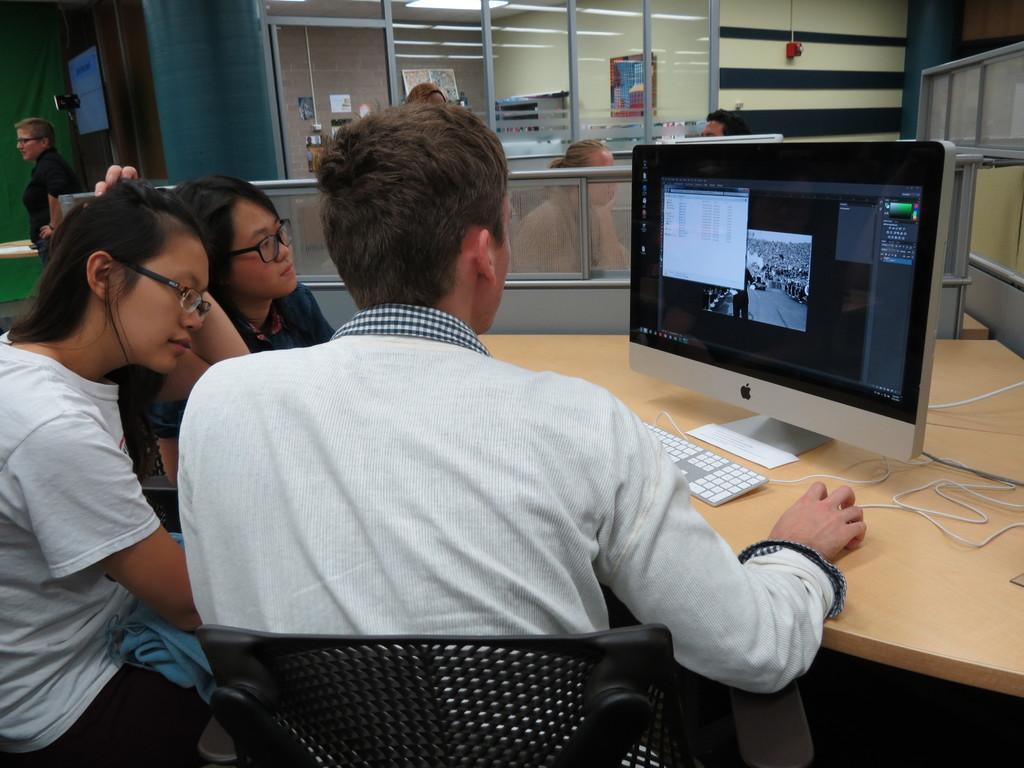Could you give a brief overview of what you see in this image? In the background we can see the glass doors. We can see boards and posters. On the left side we can see a person, wearing spectacles. In this picture we can see different cabins and people sitting. We can see a man is sitting on the chair. Beside to him we can see women, wearing spectacles. All are staring at the monitor screen. On the table we can see a keyboard. 